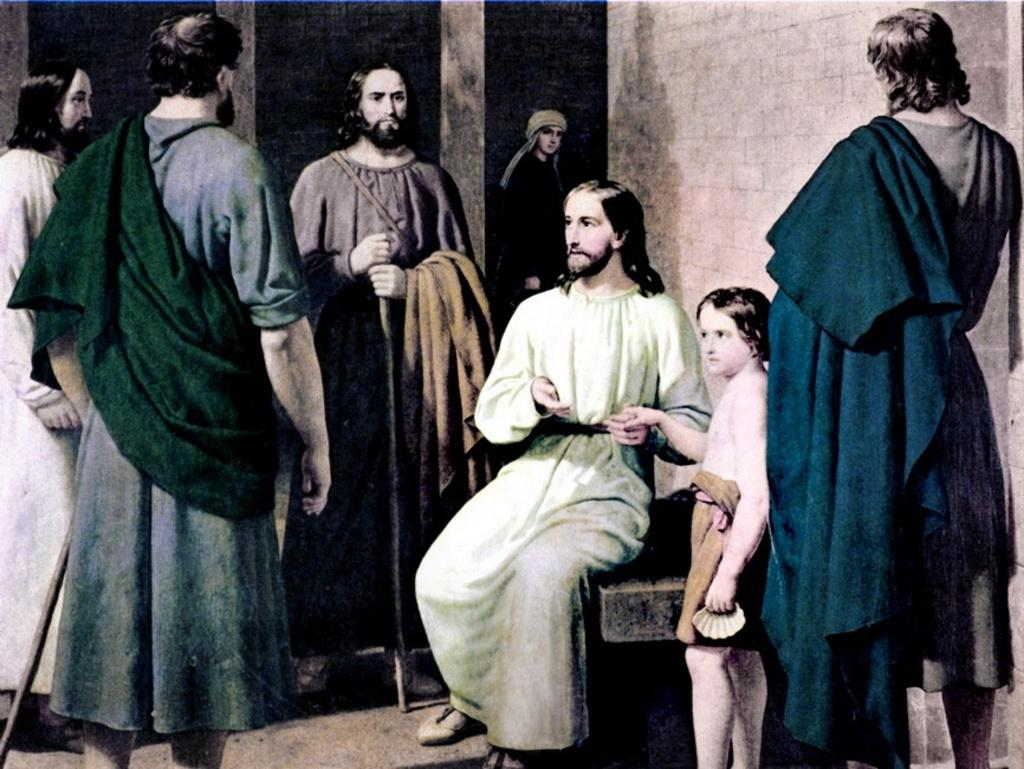What type of image is this? The image appears to be animated. Can you describe the people in the foreground of the image? There are people in the foreground of the image. What can be seen in the background of the image? There are walls in the background of the image. What type of bird is flying in the image? There is no bird present in the image; it is an animated scene with people and walls. What kind of insurance policy is being discussed by the people in the image? There is no discussion of insurance in the image; it is focused on the animated scene with people and walls. 